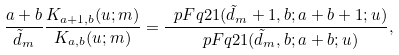<formula> <loc_0><loc_0><loc_500><loc_500>\frac { a + b } { \tilde { d } _ { m } } \frac { K _ { a + 1 , b } ( u ; m ) } { K _ { a , b } ( u ; m ) } = \frac { \ p F q 2 1 ( \tilde { d } _ { m } + 1 , b ; a + b + 1 ; u ) } { \ p F q 2 1 ( \tilde { d } _ { m } , b ; a + b ; u ) } ,</formula> 